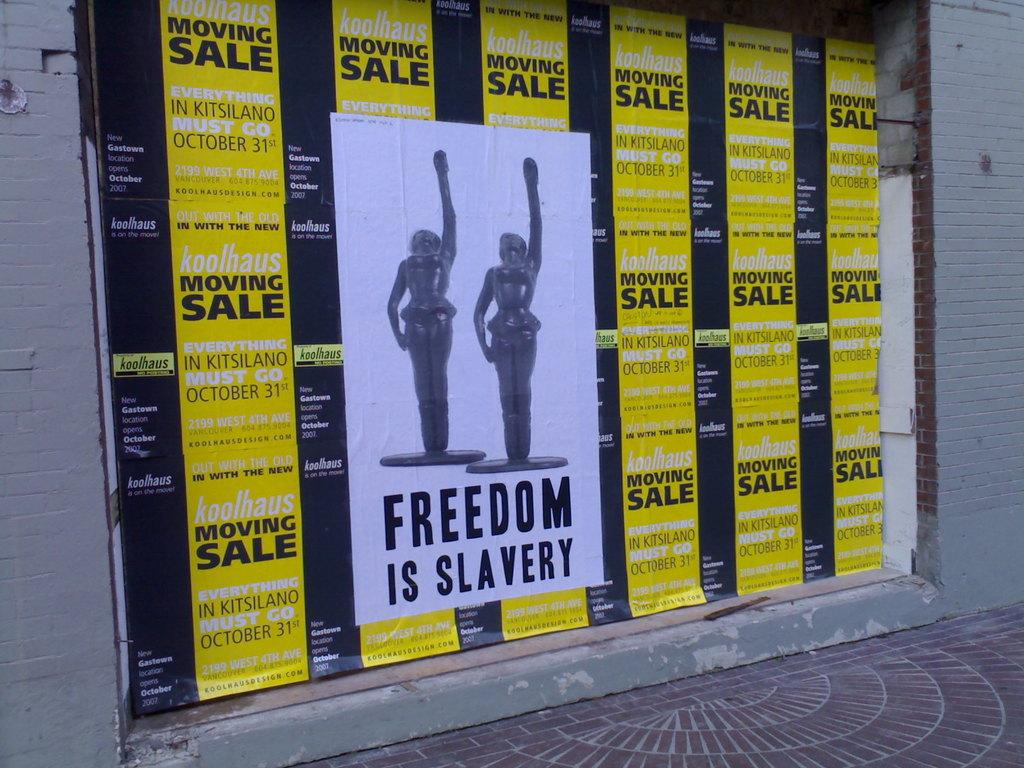What colors are combined on the board in the image? The board in the image has a yellow and black color combination. What is attached to the board? A paper is attached to the board. What can be seen behind the board in the image? The wall is visible in the image. What is visible below the board in the image? The floor is visible in the image. What type of sand can be seen on the shirt in the image? There is no shirt or sand present in the image. How does the drum contribute to the overall composition of the image? There is no drum present in the image. 